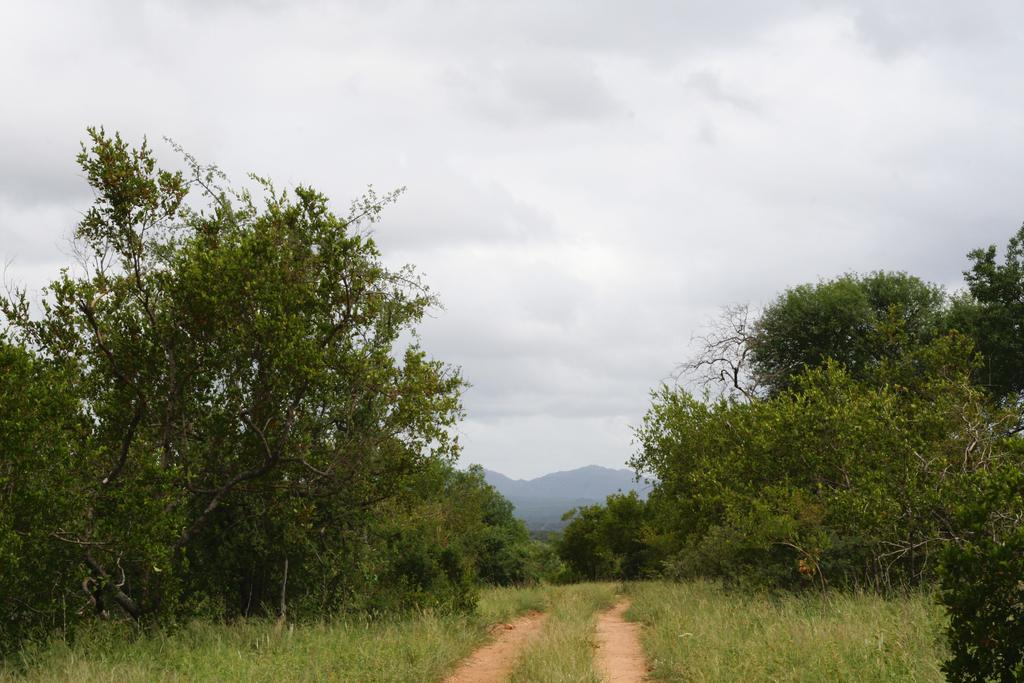What type of vegetation is in the front of the image? There are trees in the front of the image. What geographical feature can be seen in the background of the image? There is a mountain in the background of the image. What is visible at the top of the image? The sky is visible at the top of the image. What can be observed in the sky? Clouds are present in the sky. Where is the store located in the image? There is no store present in the image. What type of harmony can be heard in the image? There is no sound or music present in the image, so it is not possible to determine any harmony. 